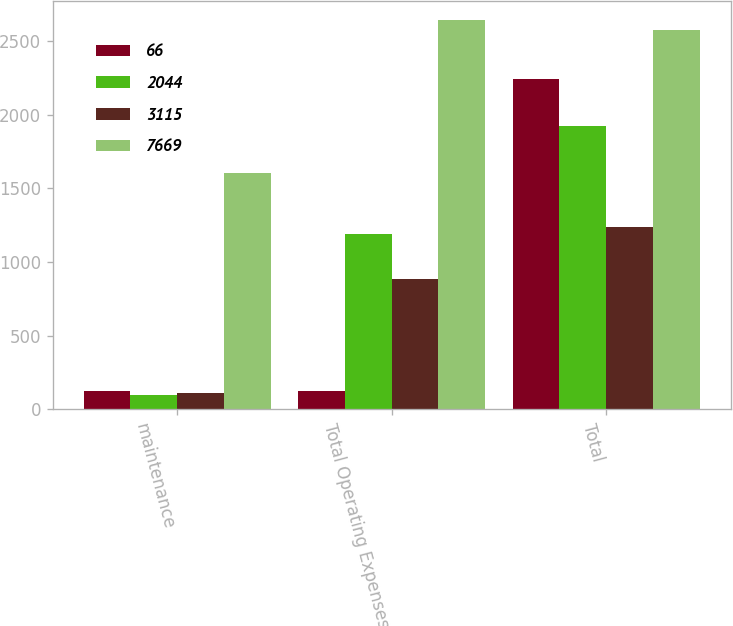Convert chart. <chart><loc_0><loc_0><loc_500><loc_500><stacked_bar_chart><ecel><fcel>maintenance<fcel>Total Operating Expenses<fcel>Total<nl><fcel>66<fcel>121<fcel>121<fcel>2243<nl><fcel>2044<fcel>100<fcel>1189<fcel>1926<nl><fcel>3115<fcel>114<fcel>887<fcel>1237<nl><fcel>7669<fcel>1603<fcel>2641<fcel>2575<nl></chart> 